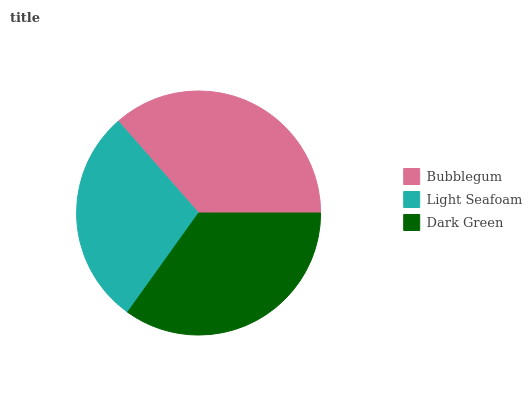Is Light Seafoam the minimum?
Answer yes or no. Yes. Is Bubblegum the maximum?
Answer yes or no. Yes. Is Dark Green the minimum?
Answer yes or no. No. Is Dark Green the maximum?
Answer yes or no. No. Is Dark Green greater than Light Seafoam?
Answer yes or no. Yes. Is Light Seafoam less than Dark Green?
Answer yes or no. Yes. Is Light Seafoam greater than Dark Green?
Answer yes or no. No. Is Dark Green less than Light Seafoam?
Answer yes or no. No. Is Dark Green the high median?
Answer yes or no. Yes. Is Dark Green the low median?
Answer yes or no. Yes. Is Light Seafoam the high median?
Answer yes or no. No. Is Bubblegum the low median?
Answer yes or no. No. 